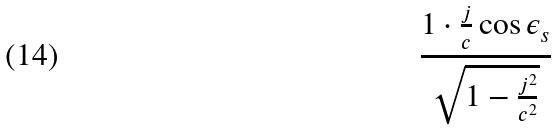<formula> <loc_0><loc_0><loc_500><loc_500>\frac { 1 \cdot \frac { j } { c } \cos \epsilon _ { s } } { \sqrt { 1 - \frac { j ^ { 2 } } { c ^ { 2 } } } }</formula> 